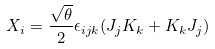<formula> <loc_0><loc_0><loc_500><loc_500>X _ { i } = \frac { \sqrt { \theta } } { 2 } \epsilon _ { i j k } ( J _ { j } K _ { k } + K _ { k } J _ { j } )</formula> 